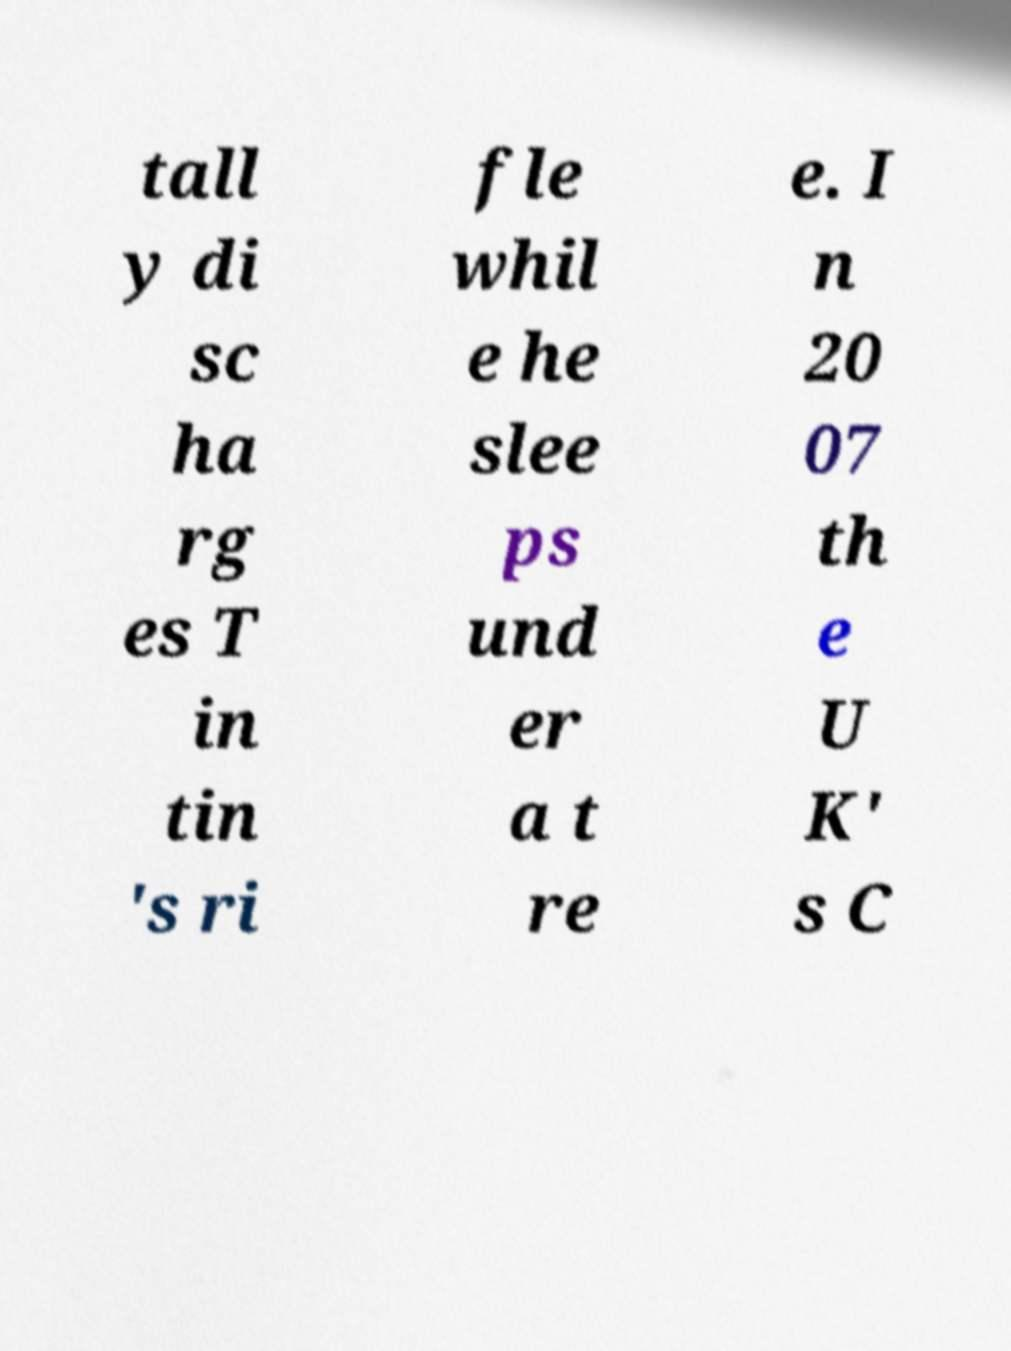Could you assist in decoding the text presented in this image and type it out clearly? tall y di sc ha rg es T in tin 's ri fle whil e he slee ps und er a t re e. I n 20 07 th e U K' s C 